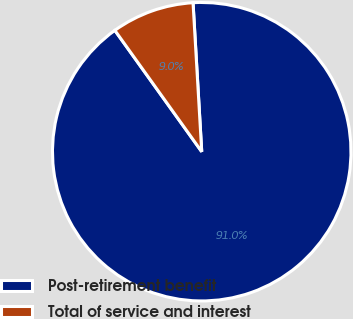Convert chart to OTSL. <chart><loc_0><loc_0><loc_500><loc_500><pie_chart><fcel>Post-retirement benefit<fcel>Total of service and interest<nl><fcel>91.04%<fcel>8.96%<nl></chart> 